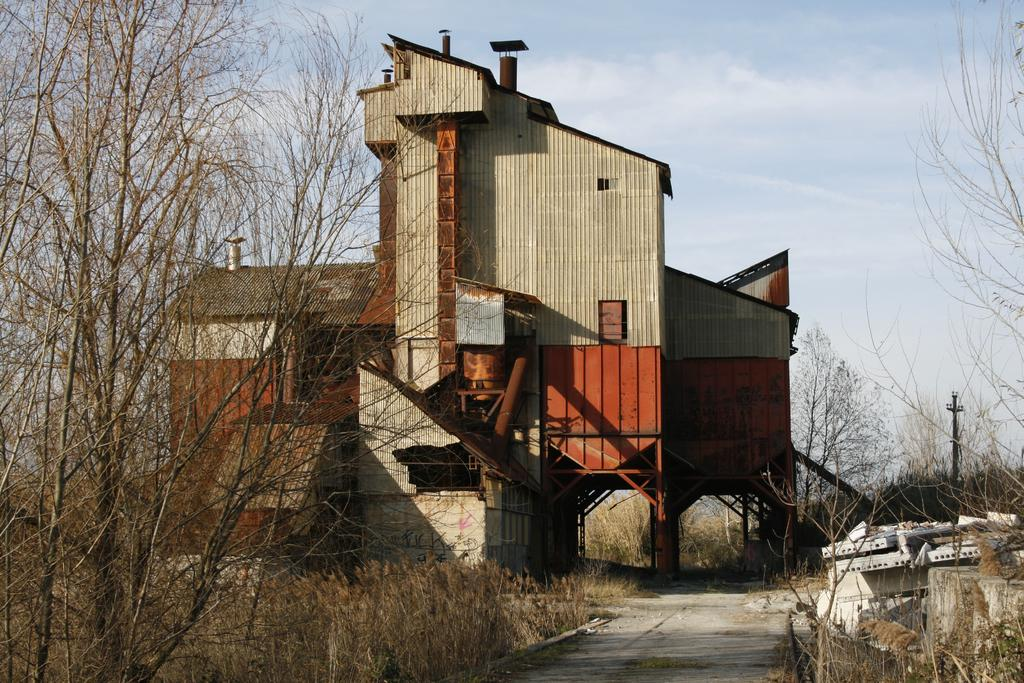What type of vegetation is on the left side of the image? There are trees on the left side of the image. What type of structure is located in the middle of the image? There appears to be a factory in the middle of the image. What is visible at the top of the image? The sky is visible at the top of the image. What type of board can be seen on the foot of the factory in the image? There is no board or foot of the factory visible in the image; it only shows trees on the left side, a factory in the middle, and the sky at the top. 